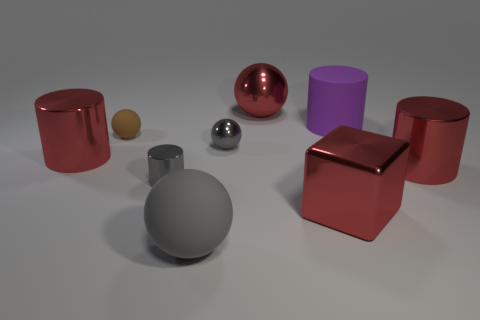Which of these objects could function as containers? Based on the image, the two red objects on the left appear to be cylindrical containers, likely capable of holding items within. Their open tops and hollow appearance indicate that they could function as vessels for various goods. 